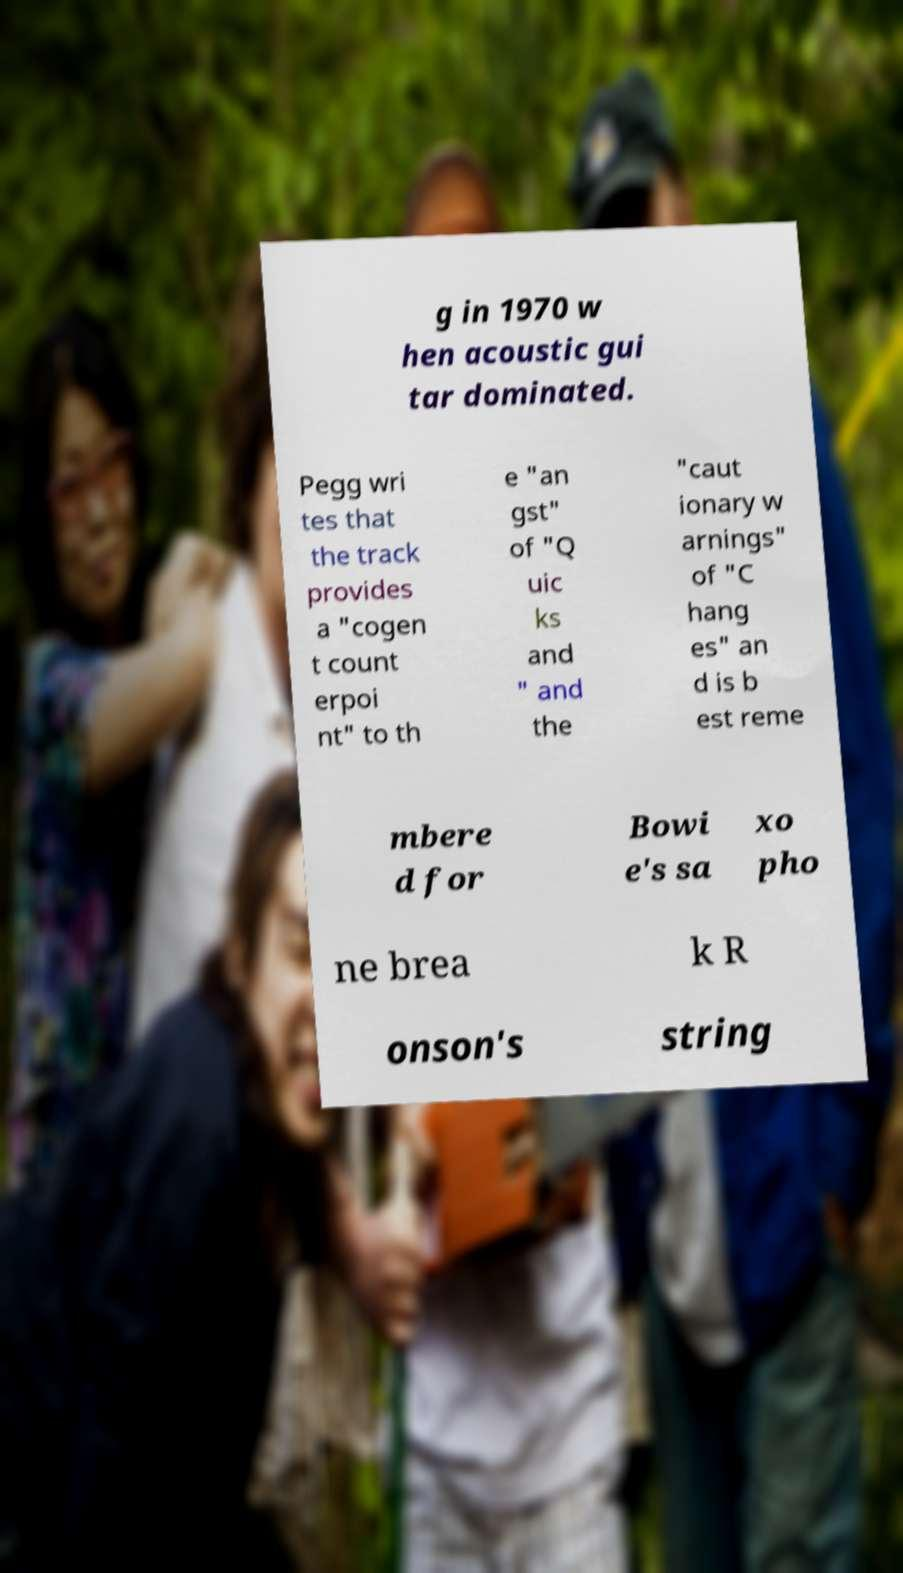Could you assist in decoding the text presented in this image and type it out clearly? g in 1970 w hen acoustic gui tar dominated. Pegg wri tes that the track provides a "cogen t count erpoi nt" to th e "an gst" of "Q uic ks and " and the "caut ionary w arnings" of "C hang es" an d is b est reme mbere d for Bowi e's sa xo pho ne brea k R onson's string 